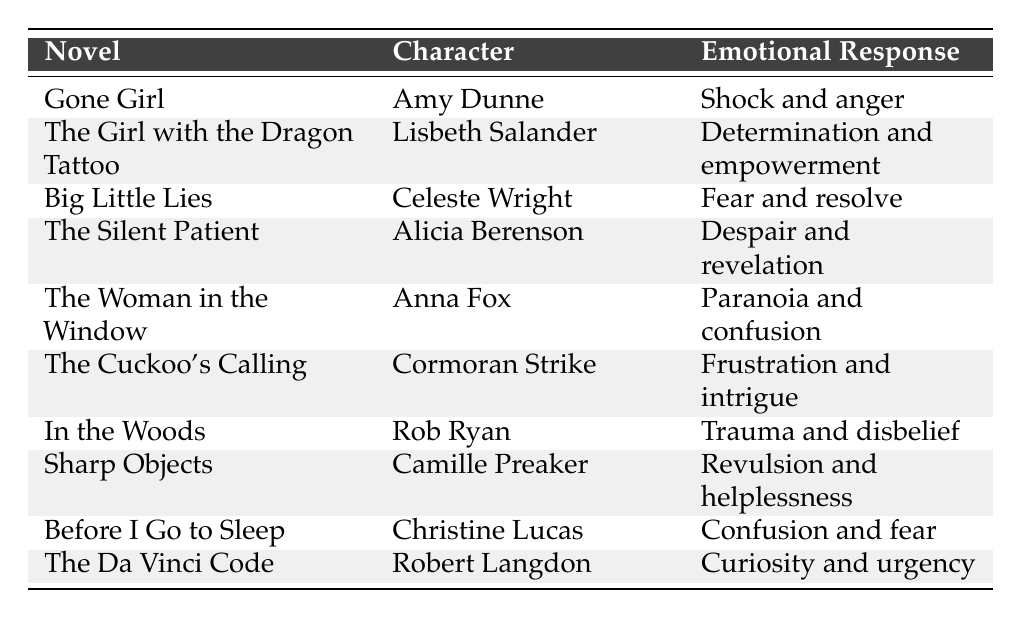What is the emotional response of Amy Dunne in "Gone Girl"? The table states that Amy Dunne's emotional response is "Shock and anger." I find this information directly under the corresponding novel in the table.
Answer: Shock and anger Which character experienced "Paranoia and confusion"? According to the table, Anna Fox from "The Woman in the Window" experienced "Paranoia and confusion" during a key plot twist.
Answer: Anna Fox How many characters express feelings of fear in the emotional responses? From the table, I can identify two characters who express feelings of fear: Celeste Wright with "Fear and resolve" and Christine Lucas with "Confusion and fear." Therefore, there are 2 characters.
Answer: 2 What emotional response is associated with the context of uncovering dark family secrets in "Sharp Objects"? The table shows that Camille Preaker expresses "Revulsion and helplessness" in the context of uncovering dark family secrets. This can be found in the row relating to her character.
Answer: Revulsion and helplessness Is there a character who responds with "Curiosity and urgency"? Yes, the table indicates that Robert Langdon from "The Da Vinci Code" shows "Curiosity and urgency." This fact can be verified by checking the table for his emotional response.
Answer: Yes Which characters have emotional responses that relate to trauma or disbelief? Rob Ryan from "In the Woods" has an emotional response of "Trauma and disbelief." Reviewing the table, he is the only character who fits this description.
Answer: Rob Ryan What is the difference between the emotional responses for Alicia Berenson and Celeste Wright? Alicia Berenson feels "Despair and revelation," while Celeste Wright feels "Fear and resolve." The difference is that there is a mix of despair with revelation versus fear with resolve, highlighting different emotional complexities, but there isn’t a numerical difference between the emotions.
Answer: N/A What complex emotional state includes both determination and empowerment? The character Lisbeth Salander from "The Girl with the Dragon Tattoo" experiences this dual emotional state of "Determination and empowerment," indicated in the table under her character listing.
Answer: Lisbeth Salander Which characters experience emotions linked to revelation? The table shows that both Alicia Berenson ("Despair and revelation") and Amy Dunne ("Shock and anger") have emotional responses associated with revelation. However, Amy also has shock and anger as part of her emotional complexity.
Answer: Alicia Berenson, Amy Dunne Can you identify a character whose emotional response changed drastically due to an investigation? Alicia Berenson's emotional response of "Despair and revelation" was due to the investigation revealing her motivations for becoming mute after the murder, indicating a significant change in emotional perspective.
Answer: Alicia Berenson 